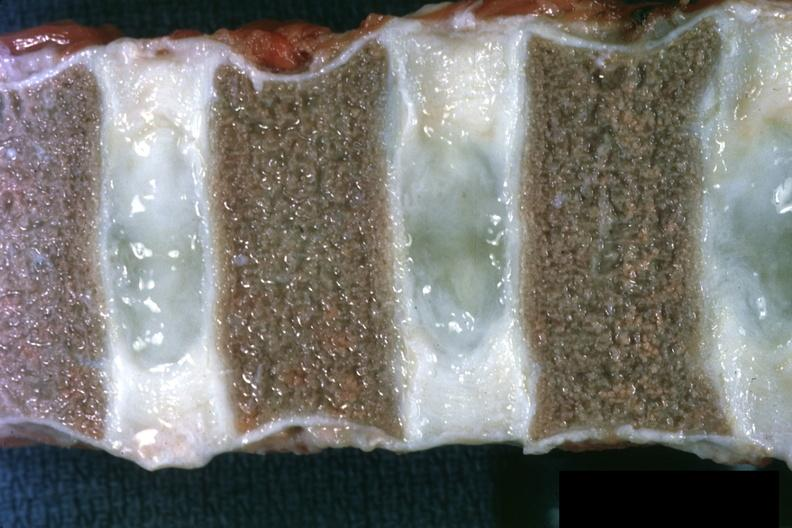re teeth well shown?
Answer the question using a single word or phrase. No 